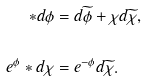<formula> <loc_0><loc_0><loc_500><loc_500>\ast d \phi & = d \widetilde { \phi } + \chi d \widetilde { \chi } , \\ \\ e ^ { \phi } \ast d \chi & = e ^ { - \phi } d \widetilde { \chi } .</formula> 